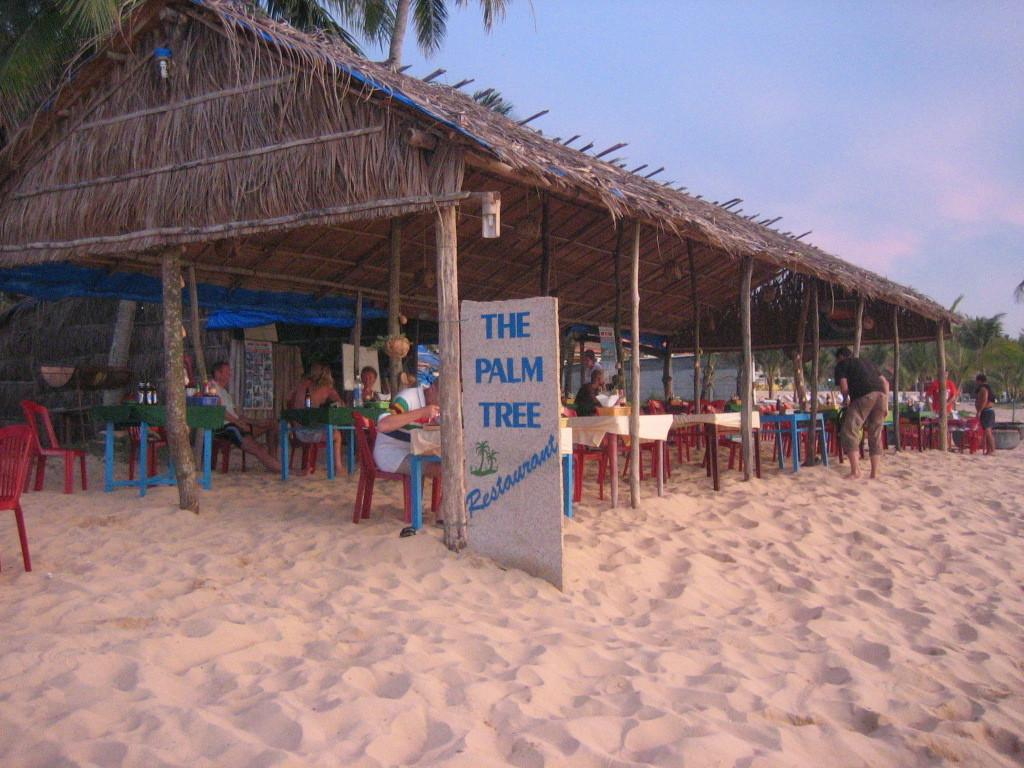What is happening in the image involving people? In the image, there are people standing and sitting on chairs. Can you describe the shed in the image? The shed in the image is brown in color. What type of vegetation is present in the image? There are trees in the image, which are green in color. What can be seen in the sky in the image? The sky in the image is blue in color. What type of berry is being used to create the wax sculpture in the image? There is no berry or wax sculpture present in the image. 